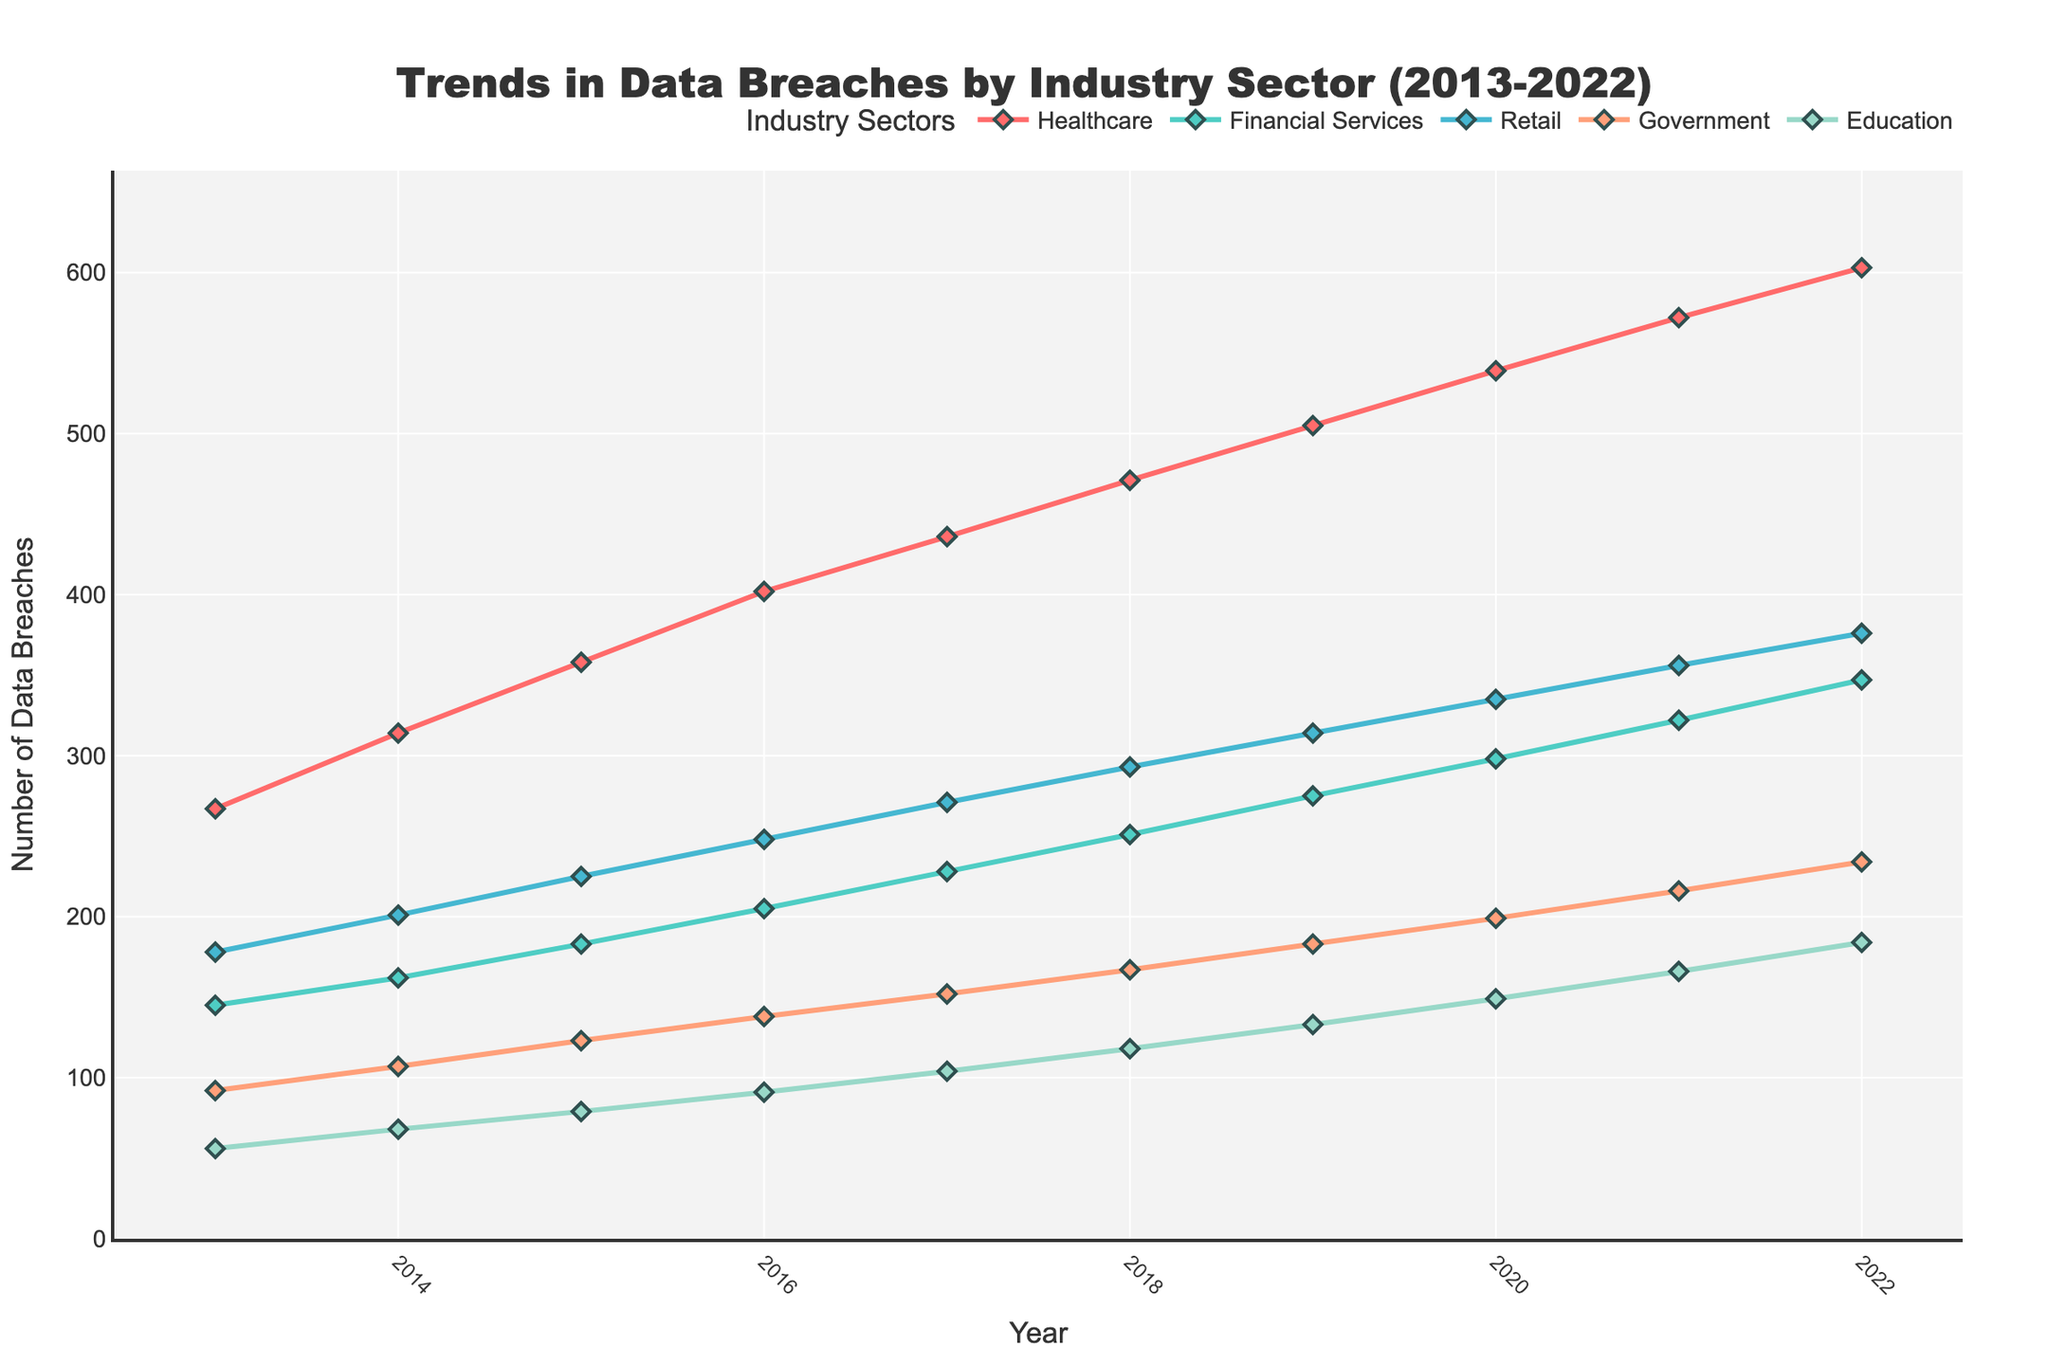What's the overall trend for data breaches in the Healthcare sector from 2013 to 2022? The Healthcare sector shows a steady increase in the number of data breaches each year from 267 breaches in 2013 to 603 breaches in 2022. To determine the trend, observe how the number of breaches rises consistently year after year.
Answer: Increasing Which industry had the highest number of data breaches in 2022? By looking at the endpoints of the lines in 2022, the Healthcare sector shows the highest number of breaches with 603 breaches compared to the other sectors.
Answer: Healthcare In which year did the Retail sector surpass 300 data breaches for the first time? Follow the line representing the Retail sector and observe the labels; in 2019, the number of data breaches surpassed 300 for the first time, reaching 314.
Answer: 2019 Which industry had the smallest increase in data breaches from 2013 to 2022? Compare the difference in breaches for each sector from 2013 to 2022. The Education sector increased from 56 to 184, giving an increase of 128, which is the smallest increase compared to other sectors.
Answer: Education What is the average annual increase in data breaches for the Financial Services sector? Determine the total increase from 145 breaches in 2013 to 347 breaches in 2022. Then, divide by the number of years (2022 - 2013 = 9 years). The total increase is 347 - 145 = 202 breaches, so the average annual increase is 202 / 9 ≈ 22.44 breaches per year.
Answer: 22.44 Which sector showed the most consistent increase (least fluctuation) over the years? By examining the smoothness and steadiness of the lines over the years, the Healthcare sector shows the most consistent increase without major fluctuations.
Answer: Healthcare Between which two consecutive years did Education see the largest increase in data breaches? Observe the slope changes in the Education sector line. The largest jump happens between 2021 (166 breaches) and 2022 (184 breaches), an increase of 18 breaches.
Answer: 2021 and 2022 For the Retail sector, what is the sum of data breaches from 2018 to 2022? Add the values for the Retail sector from 2018 to 2022: 293 (2018) + 314 (2019) + 335 (2020) + 356 (2021) + 376 (2022). The sum is 1674 breaches.
Answer: 1674 What is the average number of breaches per year in the Government sector across the decade? Sum the number of breaches for each year in the Government sector from 2013 to 2022 and divide by the number of years (10). The total sum is 92 + 107 + 123 + 138 + 152 + 167 + 183 + 199 + 216 + 234 = 1611. The average is 1611 / 10 = 161.1.
Answer: 161.1 